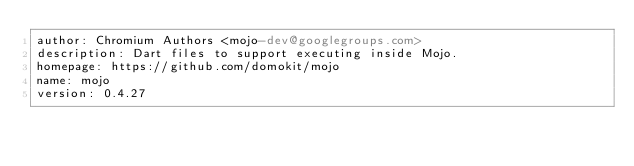<code> <loc_0><loc_0><loc_500><loc_500><_YAML_>author: Chromium Authors <mojo-dev@googlegroups.com>
description: Dart files to support executing inside Mojo.
homepage: https://github.com/domokit/mojo
name: mojo
version: 0.4.27
</code> 